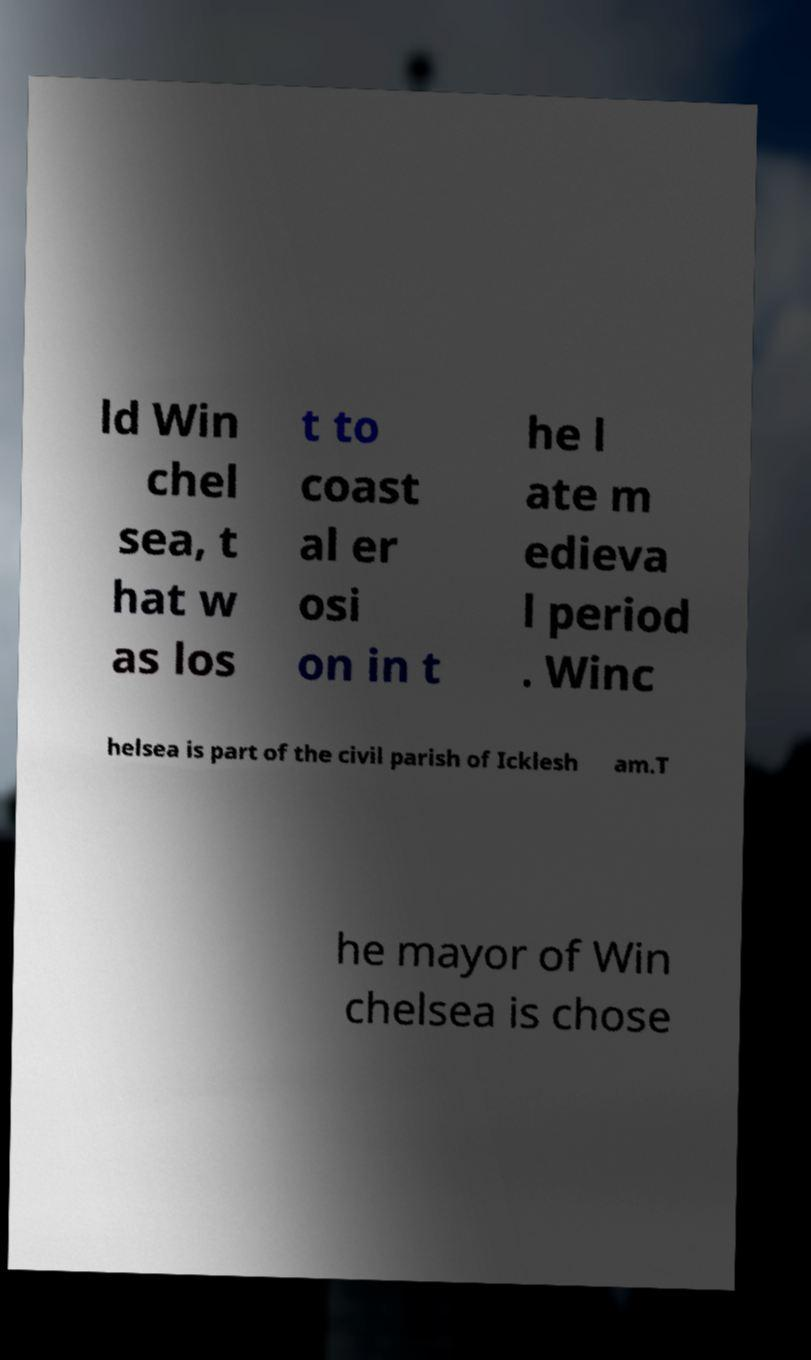Could you extract and type out the text from this image? ld Win chel sea, t hat w as los t to coast al er osi on in t he l ate m edieva l period . Winc helsea is part of the civil parish of Icklesh am.T he mayor of Win chelsea is chose 